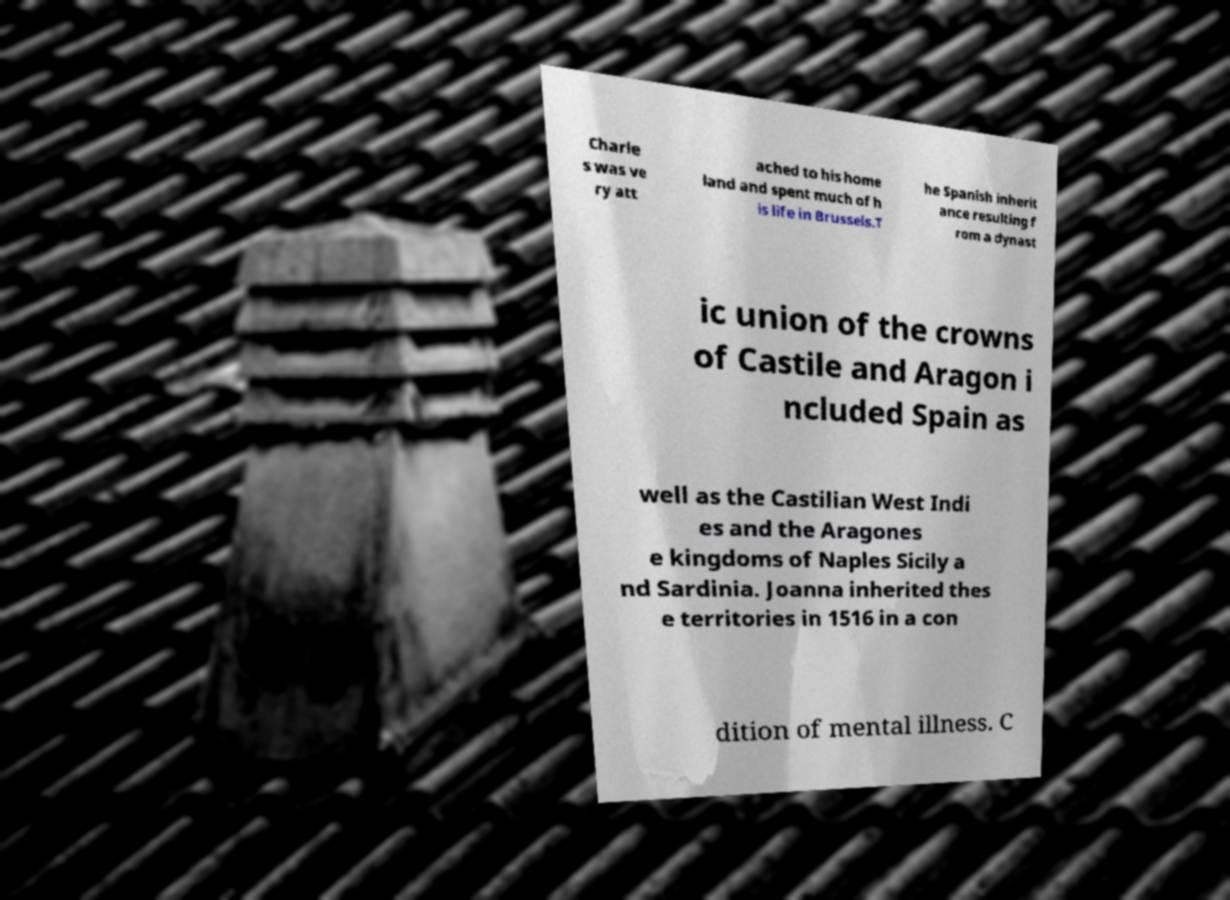Please read and relay the text visible in this image. What does it say? Charle s was ve ry att ached to his home land and spent much of h is life in Brussels.T he Spanish inherit ance resulting f rom a dynast ic union of the crowns of Castile and Aragon i ncluded Spain as well as the Castilian West Indi es and the Aragones e kingdoms of Naples Sicily a nd Sardinia. Joanna inherited thes e territories in 1516 in a con dition of mental illness. C 